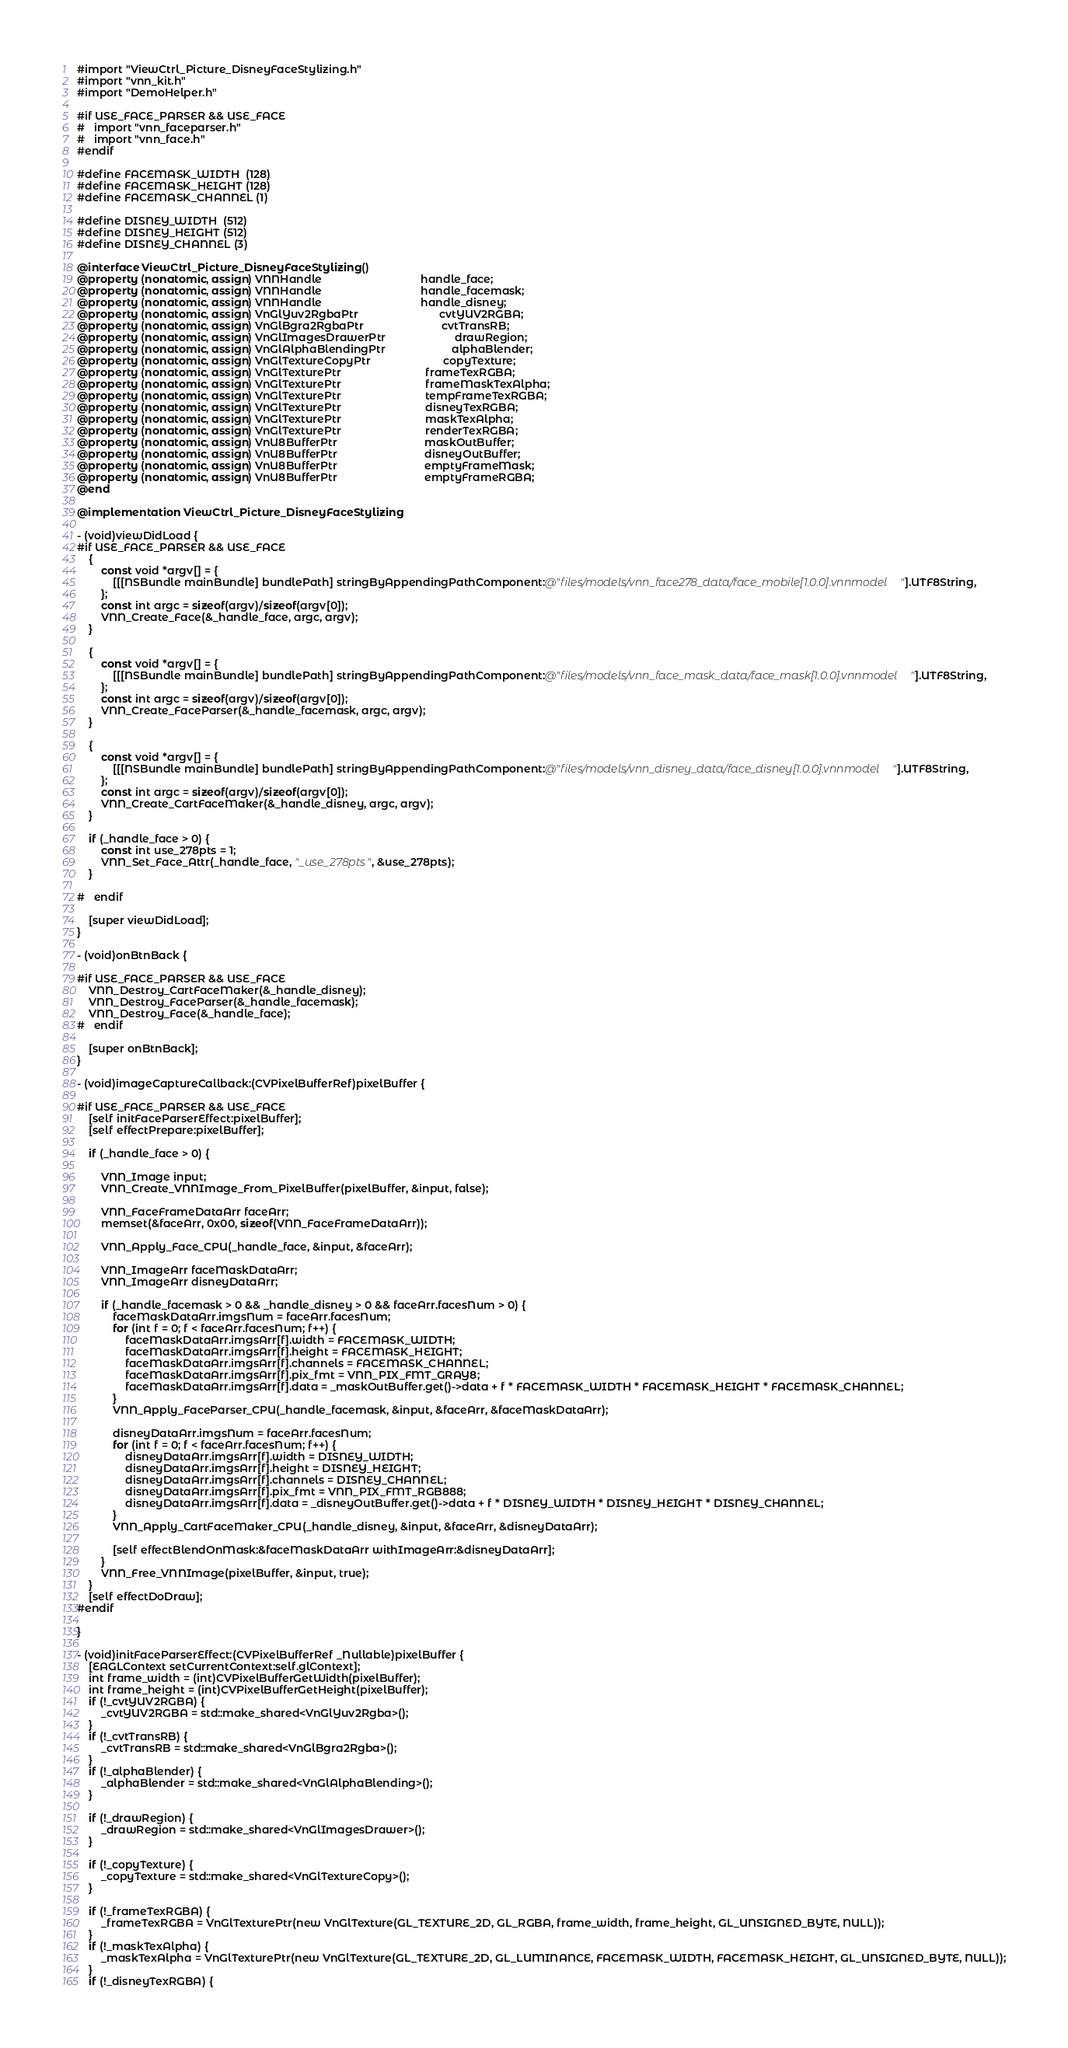Convert code to text. <code><loc_0><loc_0><loc_500><loc_500><_ObjectiveC_>#import "ViewCtrl_Picture_DisneyFaceStylizing.h"
#import "vnn_kit.h"
#import "DemoHelper.h"

#if USE_FACE_PARSER && USE_FACE
#   import "vnn_faceparser.h"
#   import "vnn_face.h"
#endif

#define FACEMASK_WIDTH  (128)
#define FACEMASK_HEIGHT (128)
#define FACEMASK_CHANNEL (1)

#define DISNEY_WIDTH  (512)
#define DISNEY_HEIGHT (512)
#define DISNEY_CHANNEL (3)

@interface ViewCtrl_Picture_DisneyFaceStylizing ()
@property (nonatomic, assign) VNNHandle                                 handle_face;
@property (nonatomic, assign) VNNHandle                                 handle_facemask;
@property (nonatomic, assign) VNNHandle                                 handle_disney;
@property (nonatomic, assign) VnGlYuv2RgbaPtr                           cvtYUV2RGBA;
@property (nonatomic, assign) VnGlBgra2RgbaPtr                          cvtTransRB;
@property (nonatomic, assign) VnGlImagesDrawerPtr                       drawRegion;
@property (nonatomic, assign) VnGlAlphaBlendingPtr                      alphaBlender;
@property (nonatomic, assign) VnGlTextureCopyPtr                        copyTexture;
@property (nonatomic, assign) VnGlTexturePtr                            frameTexRGBA;
@property (nonatomic, assign) VnGlTexturePtr                            frameMaskTexAlpha;
@property (nonatomic, assign) VnGlTexturePtr                            tempFrameTexRGBA;
@property (nonatomic, assign) VnGlTexturePtr                            disneyTexRGBA;
@property (nonatomic, assign) VnGlTexturePtr                            maskTexAlpha;
@property (nonatomic, assign) VnGlTexturePtr                            renderTexRGBA;
@property (nonatomic, assign) VnU8BufferPtr                             maskOutBuffer;
@property (nonatomic, assign) VnU8BufferPtr                             disneyOutBuffer;
@property (nonatomic, assign) VnU8BufferPtr                             emptyFrameMask;
@property (nonatomic, assign) VnU8BufferPtr                             emptyFrameRGBA;
@end

@implementation ViewCtrl_Picture_DisneyFaceStylizing

- (void)viewDidLoad {
#if USE_FACE_PARSER && USE_FACE
    {
        const void *argv[] = {
            [[[NSBundle mainBundle] bundlePath] stringByAppendingPathComponent:@"files/models/vnn_face278_data/face_mobile[1.0.0].vnnmodel"].UTF8String,
        };
        const int argc = sizeof(argv)/sizeof(argv[0]);
        VNN_Create_Face(&_handle_face, argc, argv);
    }
    
    {
        const void *argv[] = {
            [[[NSBundle mainBundle] bundlePath] stringByAppendingPathComponent:@"files/models/vnn_face_mask_data/face_mask[1.0.0].vnnmodel"].UTF8String,
        };
        const int argc = sizeof(argv)/sizeof(argv[0]);
        VNN_Create_FaceParser(&_handle_facemask, argc, argv);
    }
    
    {
        const void *argv[] = {
            [[[NSBundle mainBundle] bundlePath] stringByAppendingPathComponent:@"files/models/vnn_disney_data/face_disney[1.0.0].vnnmodel"].UTF8String,
        };
        const int argc = sizeof(argv)/sizeof(argv[0]);
        VNN_Create_CartFaceMaker(&_handle_disney, argc, argv);
    }
    
    if (_handle_face > 0) {
        const int use_278pts = 1;
        VNN_Set_Face_Attr(_handle_face, "_use_278pts", &use_278pts);
    }
    
#   endif
    
    [super viewDidLoad];
}

- (void)onBtnBack {
    
#if USE_FACE_PARSER && USE_FACE
    VNN_Destroy_CartFaceMaker(&_handle_disney);
    VNN_Destroy_FaceParser(&_handle_facemask);
    VNN_Destroy_Face(&_handle_face);
#   endif
    
    [super onBtnBack];
}

- (void)imageCaptureCallback:(CVPixelBufferRef)pixelBuffer {

#if USE_FACE_PARSER && USE_FACE
    [self initFaceParserEffect:pixelBuffer];
    [self effectPrepare:pixelBuffer];
    
    if (_handle_face > 0) {
        
        VNN_Image input;
        VNN_Create_VNNImage_From_PixelBuffer(pixelBuffer, &input, false);
        
        VNN_FaceFrameDataArr faceArr;
        memset(&faceArr, 0x00, sizeof(VNN_FaceFrameDataArr));
        
        VNN_Apply_Face_CPU(_handle_face, &input, &faceArr);
        
        VNN_ImageArr faceMaskDataArr;
        VNN_ImageArr disneyDataArr;
        
        if (_handle_facemask > 0 && _handle_disney > 0 && faceArr.facesNum > 0) {
            faceMaskDataArr.imgsNum = faceArr.facesNum;
            for (int f = 0; f < faceArr.facesNum; f++) {
                faceMaskDataArr.imgsArr[f].width = FACEMASK_WIDTH;
                faceMaskDataArr.imgsArr[f].height = FACEMASK_HEIGHT;
                faceMaskDataArr.imgsArr[f].channels = FACEMASK_CHANNEL;
                faceMaskDataArr.imgsArr[f].pix_fmt = VNN_PIX_FMT_GRAY8;
                faceMaskDataArr.imgsArr[f].data = _maskOutBuffer.get()->data + f * FACEMASK_WIDTH * FACEMASK_HEIGHT * FACEMASK_CHANNEL;
            }
            VNN_Apply_FaceParser_CPU(_handle_facemask, &input, &faceArr, &faceMaskDataArr);
            
            disneyDataArr.imgsNum = faceArr.facesNum;
            for (int f = 0; f < faceArr.facesNum; f++) {
                disneyDataArr.imgsArr[f].width = DISNEY_WIDTH;
                disneyDataArr.imgsArr[f].height = DISNEY_HEIGHT;
                disneyDataArr.imgsArr[f].channels = DISNEY_CHANNEL;
                disneyDataArr.imgsArr[f].pix_fmt = VNN_PIX_FMT_RGB888;
                disneyDataArr.imgsArr[f].data = _disneyOutBuffer.get()->data + f * DISNEY_WIDTH * DISNEY_HEIGHT * DISNEY_CHANNEL;
            }
            VNN_Apply_CartFaceMaker_CPU(_handle_disney, &input, &faceArr, &disneyDataArr);
            
            [self effectBlendOnMask:&faceMaskDataArr withImageArr:&disneyDataArr];
        }
        VNN_Free_VNNImage(pixelBuffer, &input, true);
    }
    [self effectDoDraw];
#endif
    
}

- (void)initFaceParserEffect:(CVPixelBufferRef _Nullable)pixelBuffer {
    [EAGLContext setCurrentContext:self.glContext];
    int frame_width = (int)CVPixelBufferGetWidth(pixelBuffer);
    int frame_height = (int)CVPixelBufferGetHeight(pixelBuffer);
    if (!_cvtYUV2RGBA) {
        _cvtYUV2RGBA = std::make_shared<VnGlYuv2Rgba>();
    }
    if (!_cvtTransRB) {
        _cvtTransRB = std::make_shared<VnGlBgra2Rgba>();
    }
    if (!_alphaBlender) {
        _alphaBlender = std::make_shared<VnGlAlphaBlending>();
    }
    
    if (!_drawRegion) {
        _drawRegion = std::make_shared<VnGlImagesDrawer>();
    }
    
    if (!_copyTexture) {
        _copyTexture = std::make_shared<VnGlTextureCopy>();
    }
    
    if (!_frameTexRGBA) {
        _frameTexRGBA = VnGlTexturePtr(new VnGlTexture(GL_TEXTURE_2D, GL_RGBA, frame_width, frame_height, GL_UNSIGNED_BYTE, NULL));
    }
    if (!_maskTexAlpha) {
        _maskTexAlpha = VnGlTexturePtr(new VnGlTexture(GL_TEXTURE_2D, GL_LUMINANCE, FACEMASK_WIDTH, FACEMASK_HEIGHT, GL_UNSIGNED_BYTE, NULL));
    }
    if (!_disneyTexRGBA) {</code> 